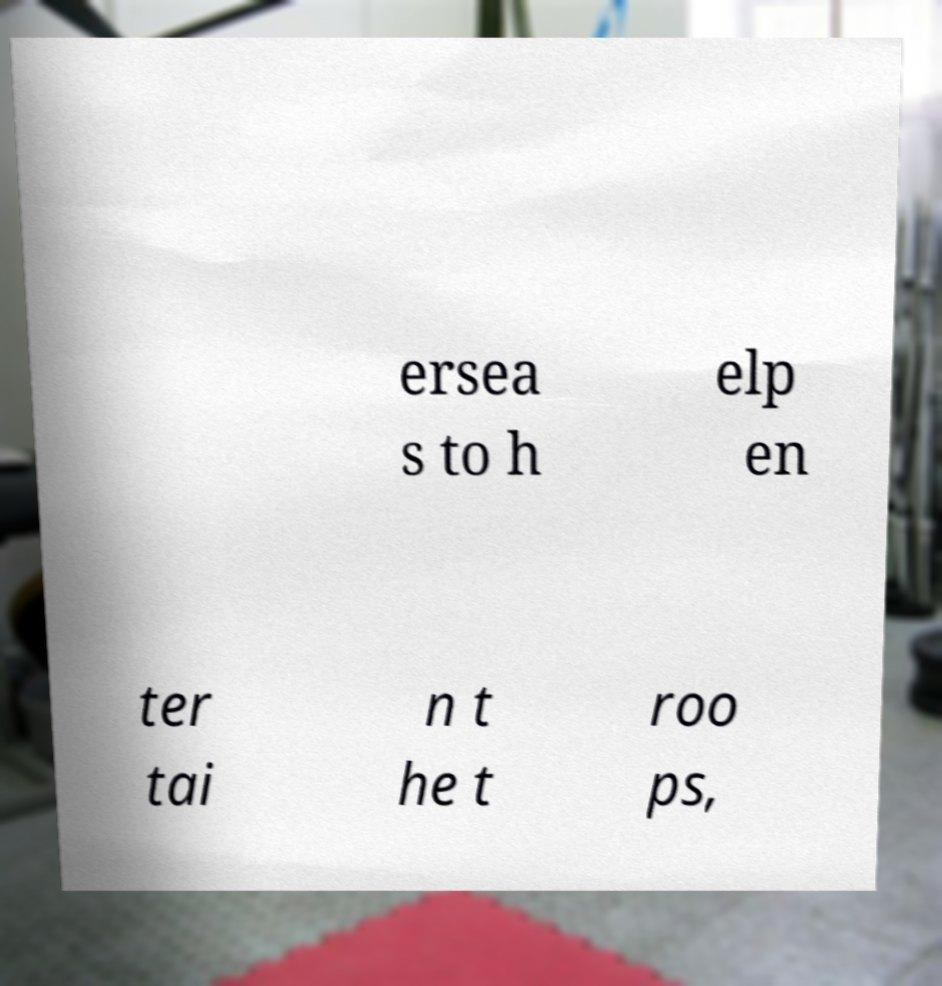Could you assist in decoding the text presented in this image and type it out clearly? ersea s to h elp en ter tai n t he t roo ps, 